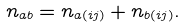Convert formula to latex. <formula><loc_0><loc_0><loc_500><loc_500>n _ { a b } = n _ { a ( i j ) } + n _ { b ( i j ) } .</formula> 